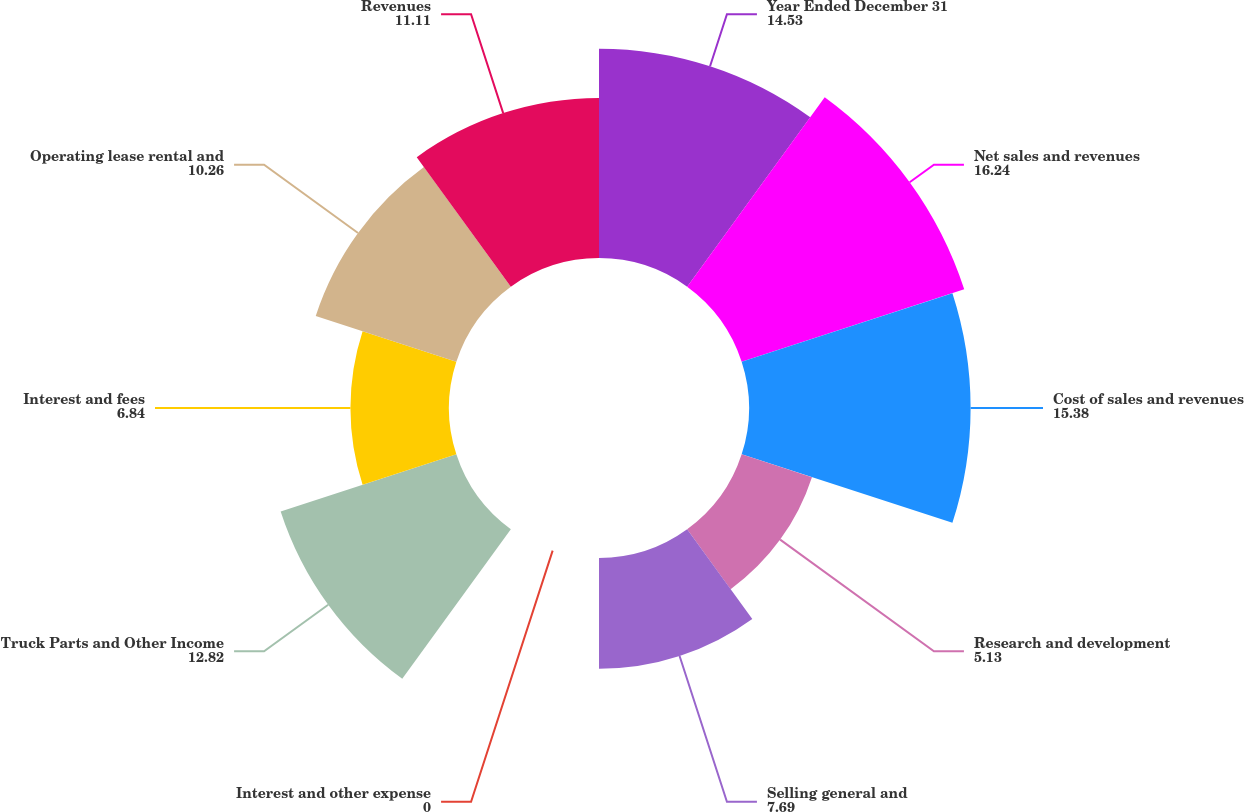Convert chart. <chart><loc_0><loc_0><loc_500><loc_500><pie_chart><fcel>Year Ended December 31<fcel>Net sales and revenues<fcel>Cost of sales and revenues<fcel>Research and development<fcel>Selling general and<fcel>Interest and other expense<fcel>Truck Parts and Other Income<fcel>Interest and fees<fcel>Operating lease rental and<fcel>Revenues<nl><fcel>14.53%<fcel>16.24%<fcel>15.38%<fcel>5.13%<fcel>7.69%<fcel>0.0%<fcel>12.82%<fcel>6.84%<fcel>10.26%<fcel>11.11%<nl></chart> 